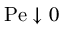Convert formula to latex. <formula><loc_0><loc_0><loc_500><loc_500>P e \downarrow 0</formula> 